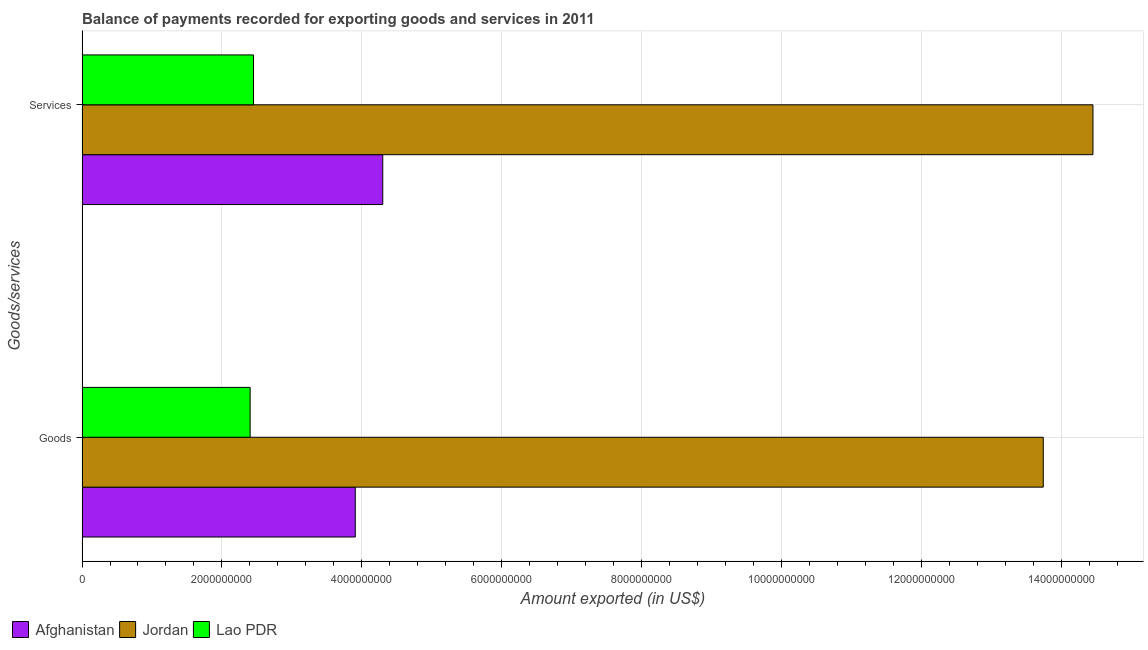How many different coloured bars are there?
Your answer should be compact. 3. Are the number of bars on each tick of the Y-axis equal?
Your answer should be very brief. Yes. How many bars are there on the 2nd tick from the bottom?
Your response must be concise. 3. What is the label of the 1st group of bars from the top?
Your answer should be compact. Services. What is the amount of services exported in Jordan?
Your answer should be compact. 1.45e+1. Across all countries, what is the maximum amount of goods exported?
Make the answer very short. 1.37e+1. Across all countries, what is the minimum amount of services exported?
Keep it short and to the point. 2.45e+09. In which country was the amount of goods exported maximum?
Your answer should be very brief. Jordan. In which country was the amount of services exported minimum?
Provide a short and direct response. Lao PDR. What is the total amount of services exported in the graph?
Your response must be concise. 2.12e+1. What is the difference between the amount of goods exported in Lao PDR and that in Jordan?
Provide a succinct answer. -1.13e+1. What is the difference between the amount of services exported in Afghanistan and the amount of goods exported in Lao PDR?
Your answer should be very brief. 1.90e+09. What is the average amount of services exported per country?
Give a very brief answer. 7.07e+09. What is the difference between the amount of goods exported and amount of services exported in Jordan?
Provide a succinct answer. -7.10e+08. In how many countries, is the amount of services exported greater than 7600000000 US$?
Provide a short and direct response. 1. What is the ratio of the amount of services exported in Jordan to that in Lao PDR?
Ensure brevity in your answer.  5.89. Is the amount of goods exported in Jordan less than that in Afghanistan?
Give a very brief answer. No. In how many countries, is the amount of goods exported greater than the average amount of goods exported taken over all countries?
Your answer should be very brief. 1. What does the 2nd bar from the top in Services represents?
Keep it short and to the point. Jordan. What does the 2nd bar from the bottom in Goods represents?
Provide a succinct answer. Jordan. How many bars are there?
Give a very brief answer. 6. Are all the bars in the graph horizontal?
Your answer should be compact. Yes. How many countries are there in the graph?
Your response must be concise. 3. What is the difference between two consecutive major ticks on the X-axis?
Your response must be concise. 2.00e+09. Where does the legend appear in the graph?
Make the answer very short. Bottom left. What is the title of the graph?
Offer a very short reply. Balance of payments recorded for exporting goods and services in 2011. Does "Bolivia" appear as one of the legend labels in the graph?
Offer a terse response. No. What is the label or title of the X-axis?
Give a very brief answer. Amount exported (in US$). What is the label or title of the Y-axis?
Your answer should be very brief. Goods/services. What is the Amount exported (in US$) of Afghanistan in Goods?
Provide a short and direct response. 3.91e+09. What is the Amount exported (in US$) of Jordan in Goods?
Make the answer very short. 1.37e+1. What is the Amount exported (in US$) in Lao PDR in Goods?
Keep it short and to the point. 2.40e+09. What is the Amount exported (in US$) of Afghanistan in Services?
Give a very brief answer. 4.30e+09. What is the Amount exported (in US$) of Jordan in Services?
Provide a short and direct response. 1.45e+1. What is the Amount exported (in US$) of Lao PDR in Services?
Provide a short and direct response. 2.45e+09. Across all Goods/services, what is the maximum Amount exported (in US$) in Afghanistan?
Your answer should be very brief. 4.30e+09. Across all Goods/services, what is the maximum Amount exported (in US$) of Jordan?
Give a very brief answer. 1.45e+1. Across all Goods/services, what is the maximum Amount exported (in US$) in Lao PDR?
Ensure brevity in your answer.  2.45e+09. Across all Goods/services, what is the minimum Amount exported (in US$) of Afghanistan?
Your answer should be very brief. 3.91e+09. Across all Goods/services, what is the minimum Amount exported (in US$) in Jordan?
Give a very brief answer. 1.37e+1. Across all Goods/services, what is the minimum Amount exported (in US$) of Lao PDR?
Ensure brevity in your answer.  2.40e+09. What is the total Amount exported (in US$) in Afghanistan in the graph?
Keep it short and to the point. 8.21e+09. What is the total Amount exported (in US$) in Jordan in the graph?
Provide a succinct answer. 2.82e+1. What is the total Amount exported (in US$) in Lao PDR in the graph?
Provide a succinct answer. 4.86e+09. What is the difference between the Amount exported (in US$) in Afghanistan in Goods and that in Services?
Offer a very short reply. -3.93e+08. What is the difference between the Amount exported (in US$) in Jordan in Goods and that in Services?
Your response must be concise. -7.10e+08. What is the difference between the Amount exported (in US$) in Lao PDR in Goods and that in Services?
Your answer should be compact. -4.83e+07. What is the difference between the Amount exported (in US$) in Afghanistan in Goods and the Amount exported (in US$) in Jordan in Services?
Offer a very short reply. -1.05e+1. What is the difference between the Amount exported (in US$) of Afghanistan in Goods and the Amount exported (in US$) of Lao PDR in Services?
Give a very brief answer. 1.45e+09. What is the difference between the Amount exported (in US$) of Jordan in Goods and the Amount exported (in US$) of Lao PDR in Services?
Your answer should be compact. 1.13e+1. What is the average Amount exported (in US$) in Afghanistan per Goods/services?
Keep it short and to the point. 4.10e+09. What is the average Amount exported (in US$) in Jordan per Goods/services?
Offer a terse response. 1.41e+1. What is the average Amount exported (in US$) of Lao PDR per Goods/services?
Your answer should be very brief. 2.43e+09. What is the difference between the Amount exported (in US$) in Afghanistan and Amount exported (in US$) in Jordan in Goods?
Your answer should be compact. -9.84e+09. What is the difference between the Amount exported (in US$) in Afghanistan and Amount exported (in US$) in Lao PDR in Goods?
Offer a terse response. 1.50e+09. What is the difference between the Amount exported (in US$) of Jordan and Amount exported (in US$) of Lao PDR in Goods?
Your response must be concise. 1.13e+1. What is the difference between the Amount exported (in US$) of Afghanistan and Amount exported (in US$) of Jordan in Services?
Provide a succinct answer. -1.02e+1. What is the difference between the Amount exported (in US$) in Afghanistan and Amount exported (in US$) in Lao PDR in Services?
Offer a terse response. 1.85e+09. What is the difference between the Amount exported (in US$) of Jordan and Amount exported (in US$) of Lao PDR in Services?
Offer a terse response. 1.20e+1. What is the ratio of the Amount exported (in US$) in Afghanistan in Goods to that in Services?
Provide a succinct answer. 0.91. What is the ratio of the Amount exported (in US$) in Jordan in Goods to that in Services?
Your response must be concise. 0.95. What is the ratio of the Amount exported (in US$) of Lao PDR in Goods to that in Services?
Provide a succinct answer. 0.98. What is the difference between the highest and the second highest Amount exported (in US$) in Afghanistan?
Provide a succinct answer. 3.93e+08. What is the difference between the highest and the second highest Amount exported (in US$) of Jordan?
Your answer should be very brief. 7.10e+08. What is the difference between the highest and the second highest Amount exported (in US$) in Lao PDR?
Give a very brief answer. 4.83e+07. What is the difference between the highest and the lowest Amount exported (in US$) of Afghanistan?
Offer a very short reply. 3.93e+08. What is the difference between the highest and the lowest Amount exported (in US$) of Jordan?
Your response must be concise. 7.10e+08. What is the difference between the highest and the lowest Amount exported (in US$) of Lao PDR?
Give a very brief answer. 4.83e+07. 